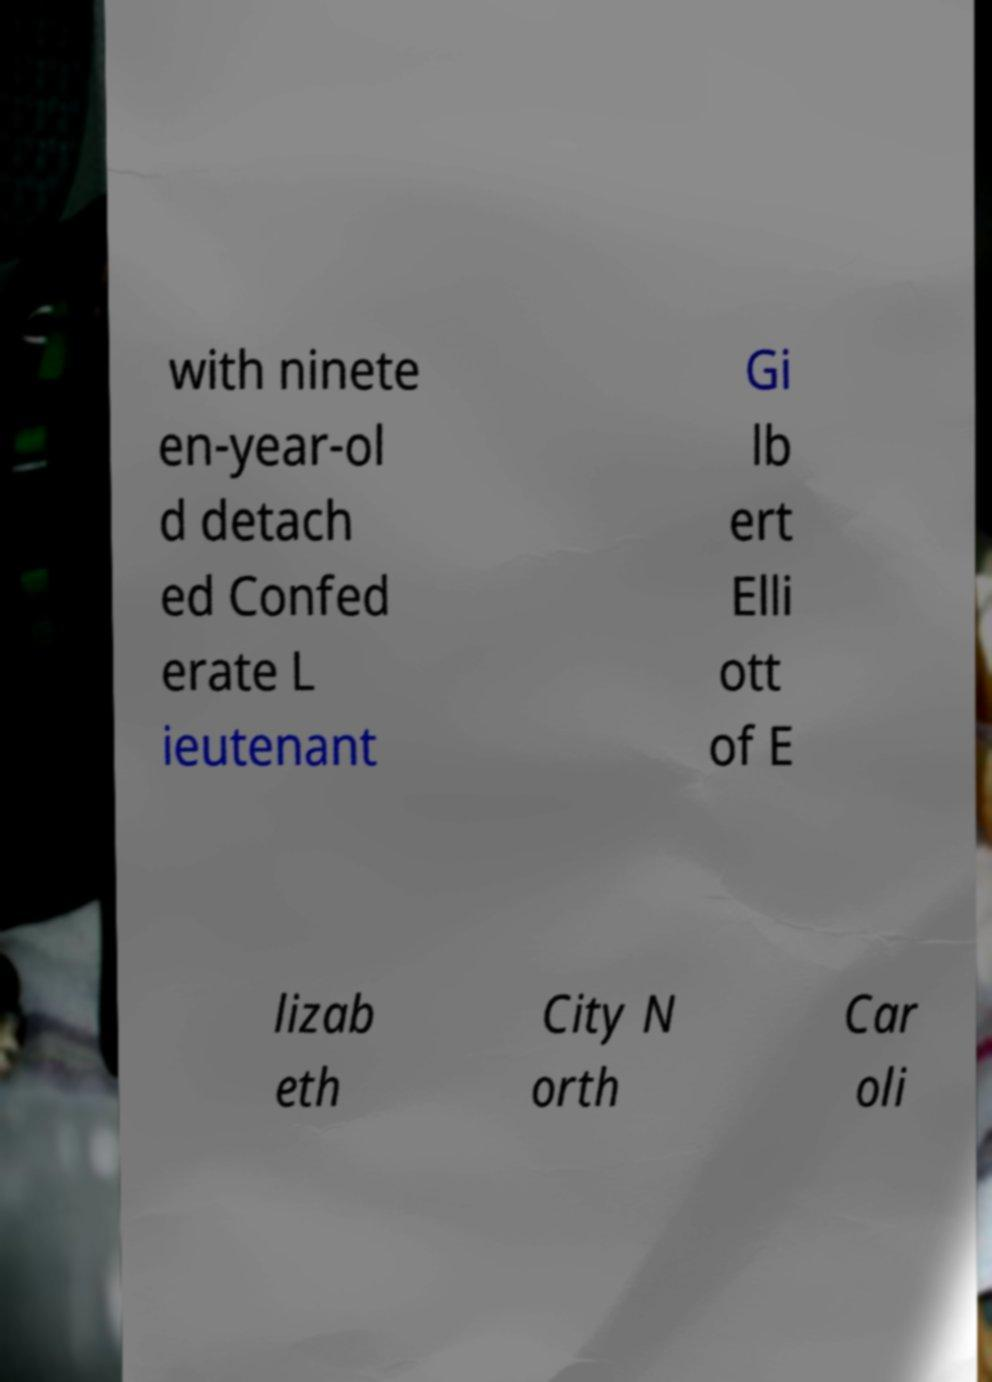Can you read and provide the text displayed in the image?This photo seems to have some interesting text. Can you extract and type it out for me? with ninete en-year-ol d detach ed Confed erate L ieutenant Gi lb ert Elli ott of E lizab eth City N orth Car oli 